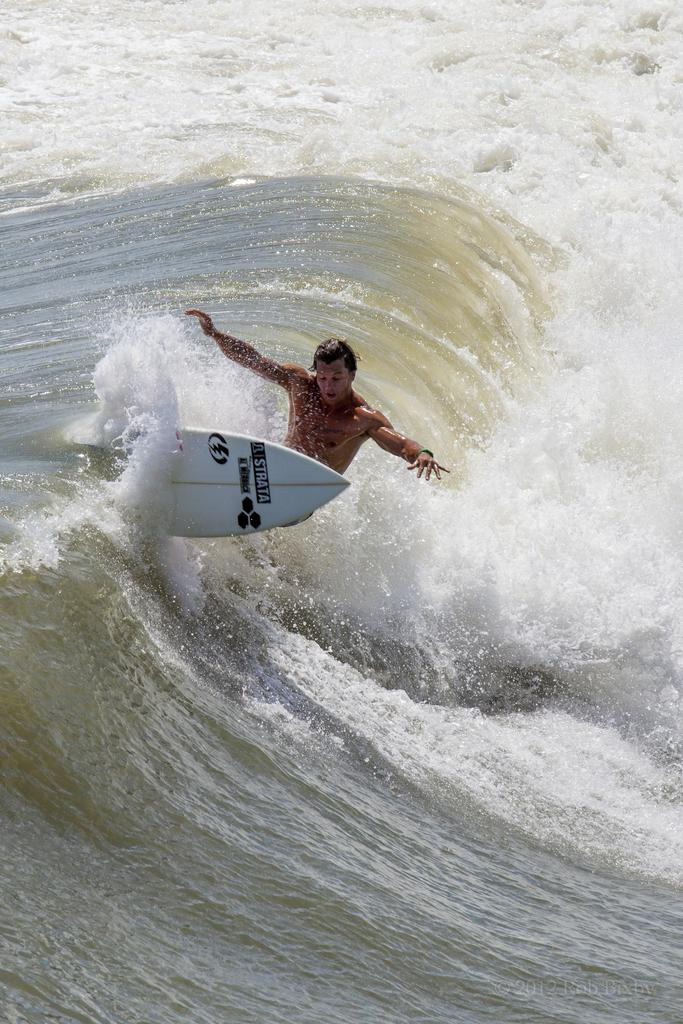Who is the main subject in the image? There is a person in the image. What is the person doing in the image? The person is riding a surfboard. Where is the surfboard located in the image? The surfboard is on water. What type of payment is being made at the party in the image? There is no party or payment present in the image; it features a person riding a surfboard on water. 